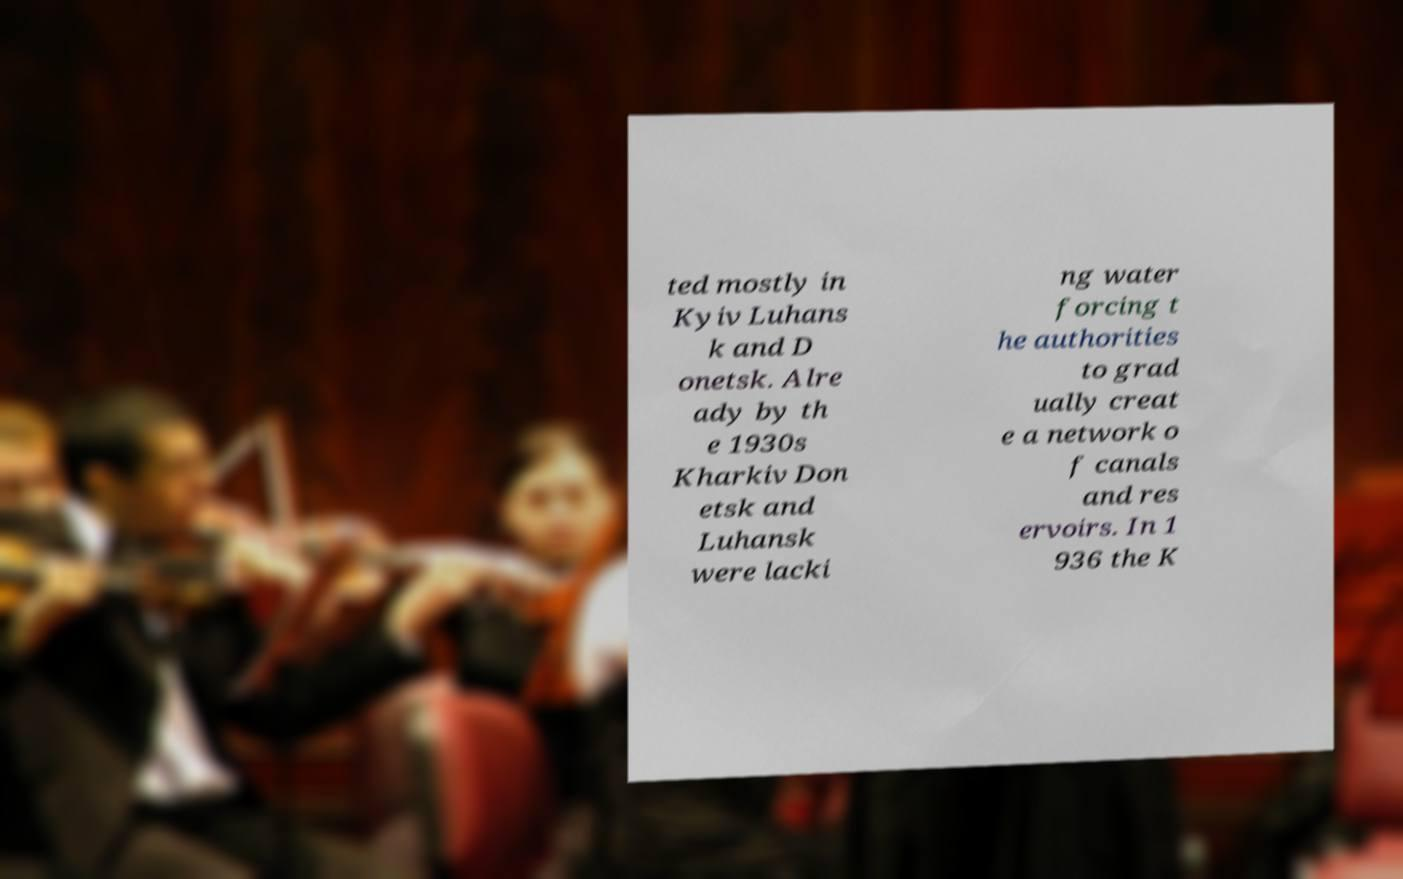Could you extract and type out the text from this image? ted mostly in Kyiv Luhans k and D onetsk. Alre ady by th e 1930s Kharkiv Don etsk and Luhansk were lacki ng water forcing t he authorities to grad ually creat e a network o f canals and res ervoirs. In 1 936 the K 